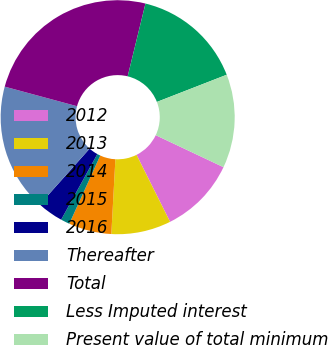Convert chart. <chart><loc_0><loc_0><loc_500><loc_500><pie_chart><fcel>2012<fcel>2013<fcel>2014<fcel>2015<fcel>2016<fcel>Thereafter<fcel>Total<fcel>Less Imputed interest<fcel>Present value of total minimum<nl><fcel>10.59%<fcel>8.25%<fcel>5.92%<fcel>1.24%<fcel>3.58%<fcel>17.6%<fcel>24.61%<fcel>15.27%<fcel>12.93%<nl></chart> 